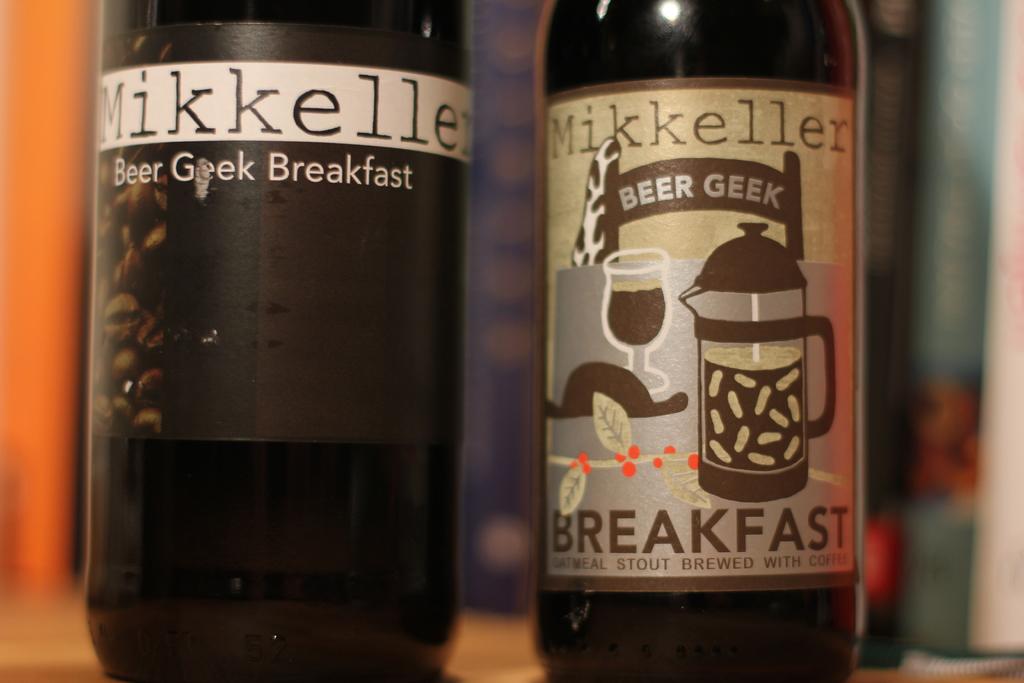What kind of beer is that?
Provide a succinct answer. Mikkeller. What meal do these beers go with?
Your answer should be very brief. Breakfast. 